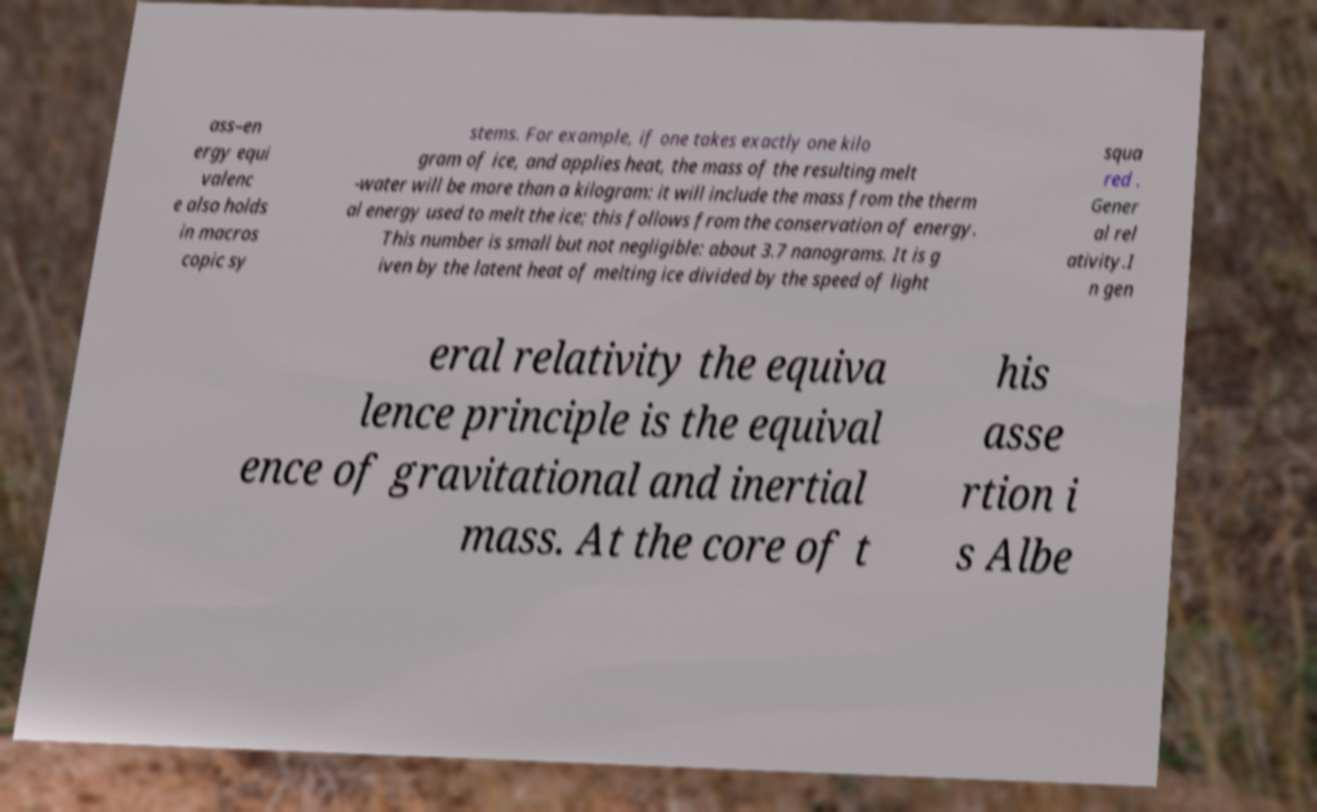For documentation purposes, I need the text within this image transcribed. Could you provide that? ass–en ergy equi valenc e also holds in macros copic sy stems. For example, if one takes exactly one kilo gram of ice, and applies heat, the mass of the resulting melt -water will be more than a kilogram: it will include the mass from the therm al energy used to melt the ice; this follows from the conservation of energy. This number is small but not negligible: about 3.7 nanograms. It is g iven by the latent heat of melting ice divided by the speed of light squa red . Gener al rel ativity.I n gen eral relativity the equiva lence principle is the equival ence of gravitational and inertial mass. At the core of t his asse rtion i s Albe 